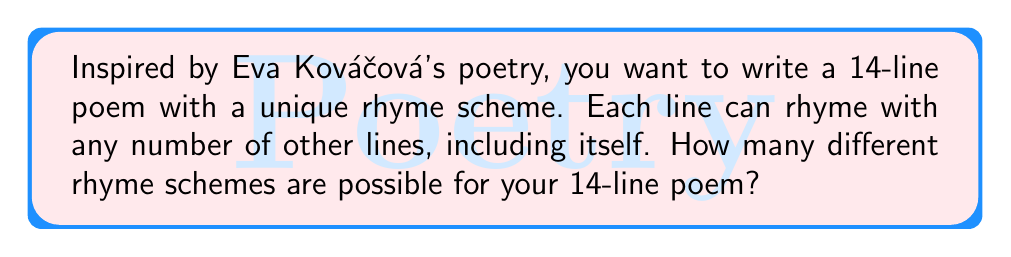Teach me how to tackle this problem. Let's approach this step-by-step:

1) Each line in the poem can be assigned a letter representing its rhyme. The first line is always assigned 'A'.

2) For each subsequent line, we have two choices:
   a) Use a letter we've already used (rhyme with a previous line)
   b) Use a new letter (introduce a new rhyme)

3) This is equivalent to the number of ways to partition a set of 14 elements, where each partition represents lines that rhyme with each other.

4) The number of ways to partition a set of n elements is given by the Bell number $B_n$.

5) For n = 14, we need to calculate $B_{14}$.

6) The Bell numbers can be calculated using the Bell triangle:
   
   $$
   \begin{array}{ccccccc}
   1 \\
   1 & 2 \\
   2 & 3 & 5 \\
   5 & 7 & 10 & 15 \\
   15 & 20 & 27 & 37 & 52 \\
   52 & 67 & 87 & 114 & 151 & 203 \\
   \vdots
   \end{array}
   $$

7) Continuing this triangle to the 14th row, the last number in that row will be $B_{14}$.

8) After calculation, we find that $B_{14} = 190,899,322$.

Therefore, there are 190,899,322 possible unique rhyme schemes for a 14-line poem.
Answer: $190,899,322$ 